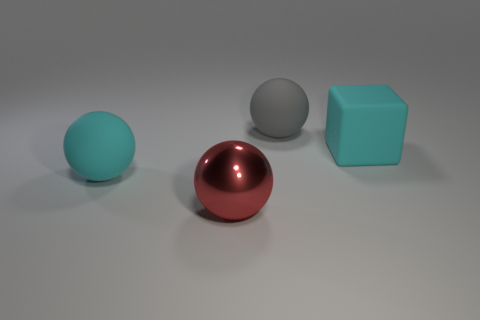Add 2 large gray spheres. How many objects exist? 6 Subtract all spheres. How many objects are left? 1 Subtract 0 purple blocks. How many objects are left? 4 Subtract all red spheres. Subtract all metallic balls. How many objects are left? 2 Add 3 rubber things. How many rubber things are left? 6 Add 3 large rubber spheres. How many large rubber spheres exist? 5 